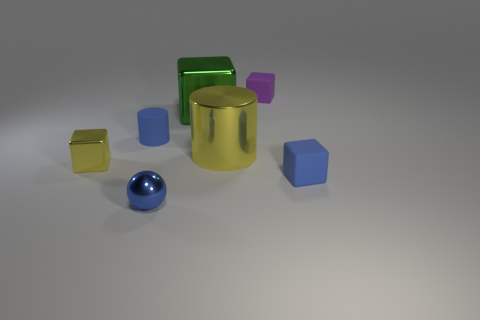Is the number of large green metal blocks that are behind the purple cube less than the number of small blue shiny balls?
Ensure brevity in your answer.  Yes. Is the yellow cube made of the same material as the yellow cylinder?
Offer a terse response. Yes. What number of things are either large brown rubber things or tiny yellow metallic objects?
Provide a short and direct response. 1. What number of cylinders are made of the same material as the tiny blue sphere?
Your response must be concise. 1. There is a green thing that is the same shape as the tiny yellow thing; what is its size?
Your response must be concise. Large. Are there any large green cubes behind the yellow metallic cylinder?
Your answer should be compact. Yes. What is the tiny blue cylinder made of?
Your response must be concise. Rubber. Does the cylinder that is on the left side of the big shiny cylinder have the same color as the sphere?
Offer a terse response. Yes. Are there any other things that are the same shape as the small blue shiny thing?
Ensure brevity in your answer.  No. What is the color of the other small rubber thing that is the same shape as the small purple matte object?
Give a very brief answer. Blue. 